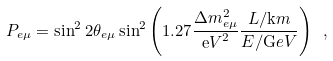Convert formula to latex. <formula><loc_0><loc_0><loc_500><loc_500>P _ { e \mu } = \sin ^ { 2 } 2 \theta _ { e \mu } \sin ^ { 2 } \left ( 1 . 2 7 \frac { \Delta m _ { e \mu } ^ { 2 } } { { \mathrm e V } ^ { 2 } } \frac { L / { \mathrm k m } } { E / { \mathrm G e V } } \right ) \ ,</formula> 